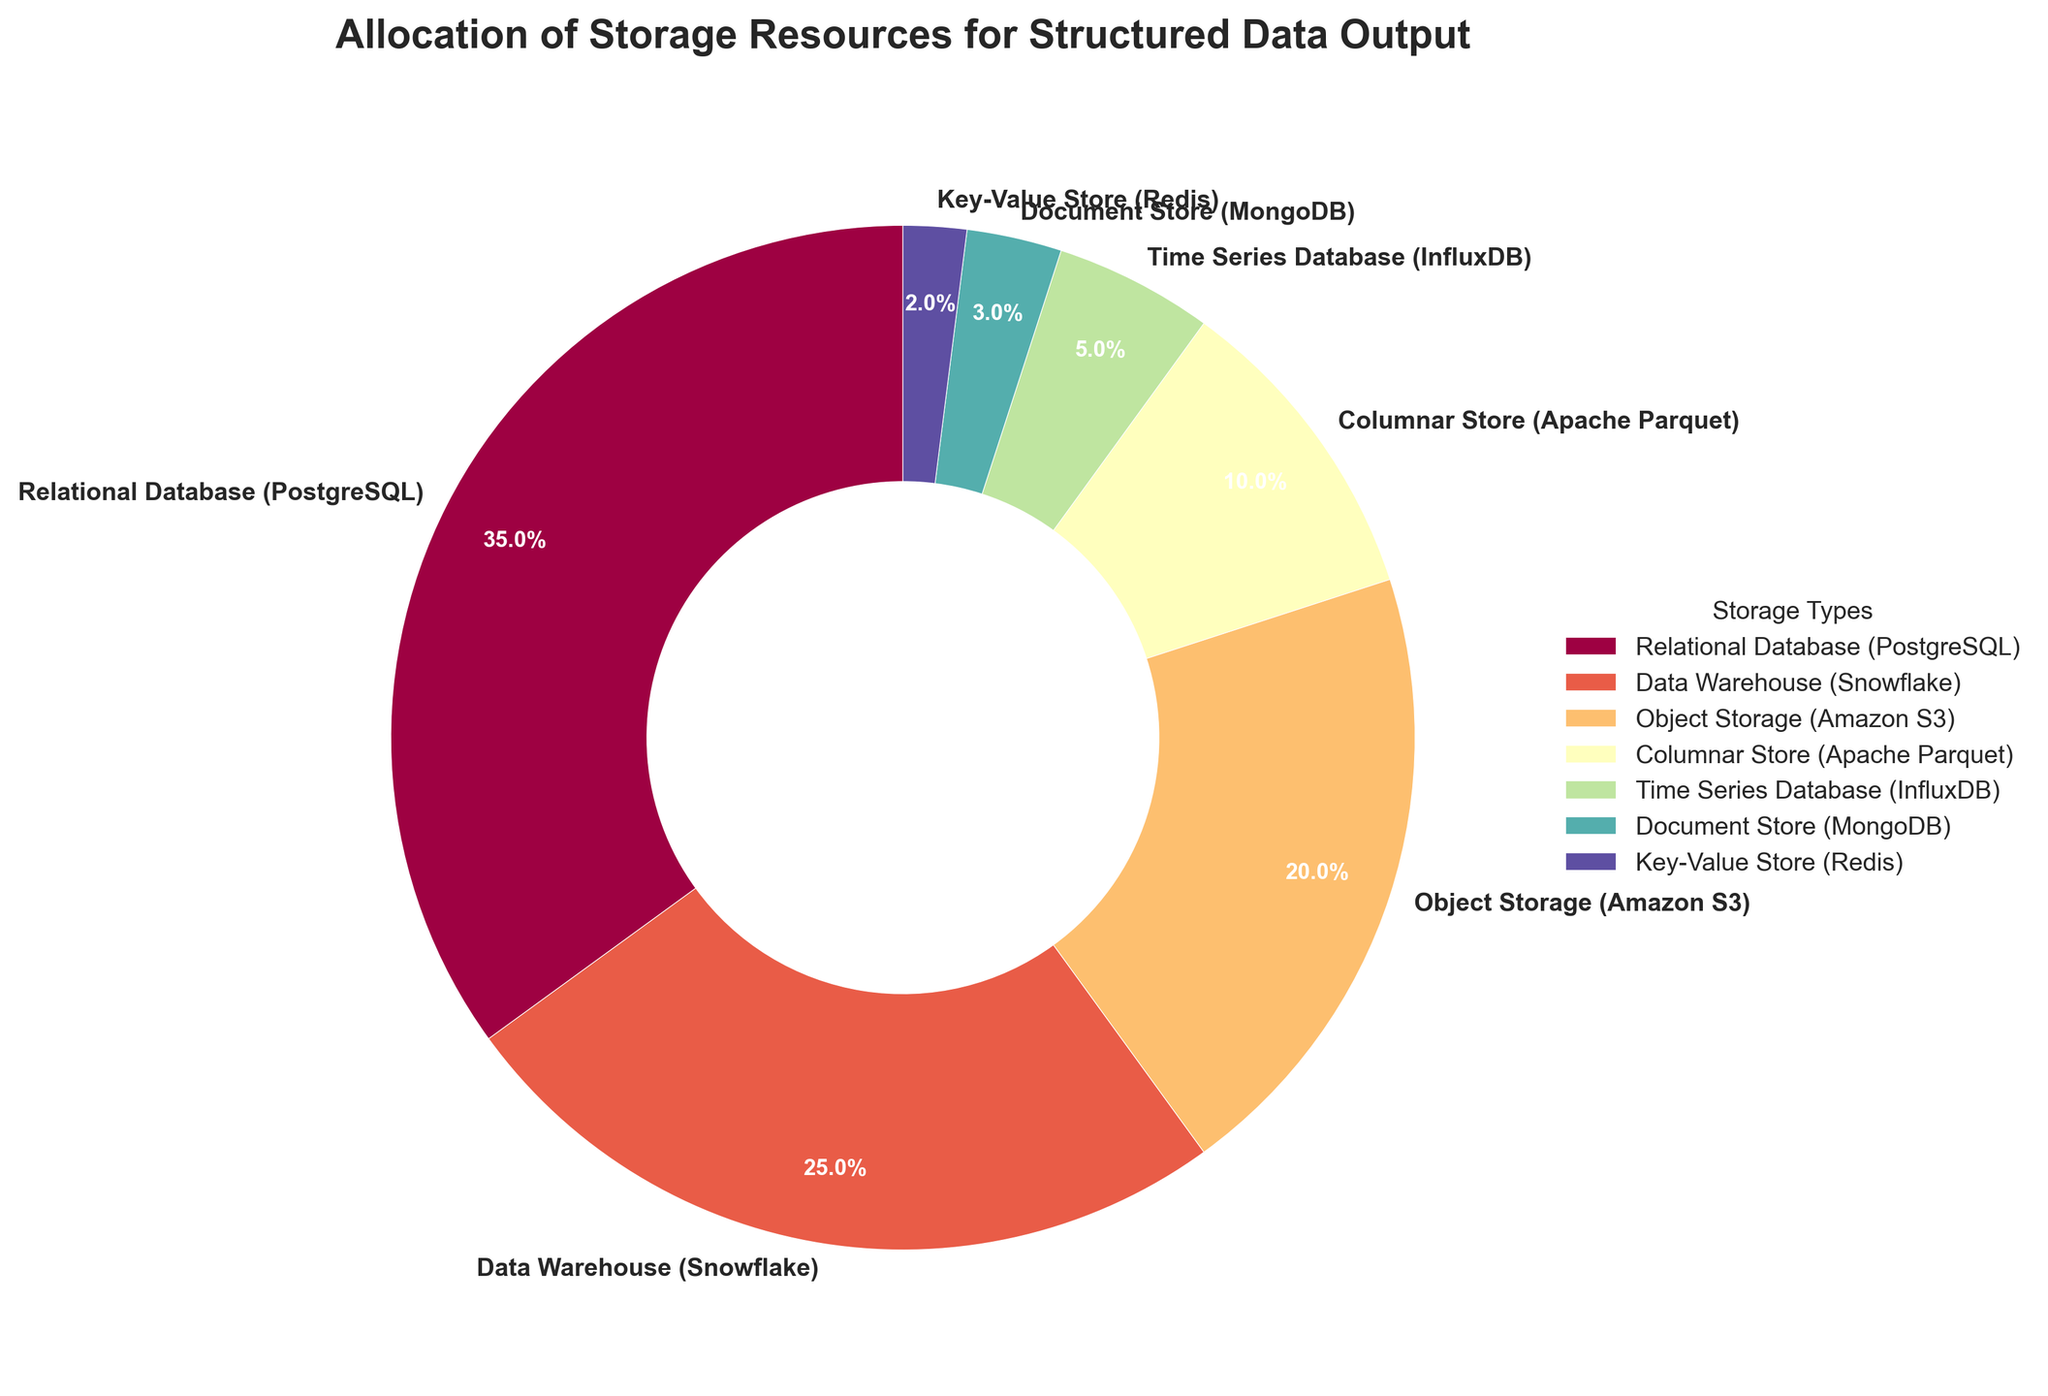What's the allocation percentage for the Relational Database (PostgreSQL)? The pie chart shows different storage types and their respective allocation percentages. Find the portion labeled "Relational Database (PostgreSQL)" and read its value.
Answer: 35% Which storage type has the smallest allocation percentage? The pie chart segments are labeled with storage types and their respective percentages. Identify the smallest percentage represented.
Answer: Key-Value Store (Redis) What is the combined allocation percentage for Object Storage (Amazon S3) and Columnar Store (Apache Parquet)? Locate the percentages for Object Storage (Amazon S3) and Columnar Store (Apache Parquet), then sum them up: 20% + 10% = 30%
Answer: 30% Compare the allocation percentages of Data Warehouse (Snowflake) and Document Store (MongoDB). Which one is larger? Find the percentages for Data Warehouse (Snowflake) and Document Store (MongoDB). The larger percentage is 25% (Snowflake) compared to 3% (MongoDB).
Answer: Data Warehouse (Snowflake) How much larger is the allocation percentage for Relational Database (PostgreSQL) compared to Time Series Database (InfluxDB)? Calculate the difference between the percentages for Relational Database (35%) and Time Series Database (5%): 35% - 5% = 30%
Answer: 30% What is the total allocation percentage for the three smallest storage types? Identify the three smallest allocation percentages: Key-Value Store (2%), Document Store (3%), and Time Series Database (5%). Sum them up: 2% + 3% + 5% = 10%
Answer: 10% Which storage type is represented by the segment with the darkest color in the pie chart? The pie chart uses a spectral color map, where darker colors typically represent larger values. Identify the darkest segment.
Answer: Relational Database (PostgreSQL) Find the ratio of allocation percentages between Object Storage (Amazon S3) and Key-Value Store (Redis). Divide the percentage for Object Storage (Amazon S3) by that for Key-Value Store (Redis): 20% / 2% = 10
Answer: 10 Compare the allocation percentages of Columnar Store (Apache Parquet) and Time Series Database (InfluxDB). Which one has a higher percentage? Locate the percentages for Columnar Store (10%) and Time Series Database (5%), and determine that 10% is higher than 5%.
Answer: Columnar Store (Apache Parquet) If we combine the percentages for Relational Database (PostgreSQL) and Data Warehouse (Snowflake), what portion of the pie chart do they represent together? Find the percentages for PostgreSQL (35%) and Snowflake (25%), then sum them up: 35% + 25% = 60%
Answer: 60% 